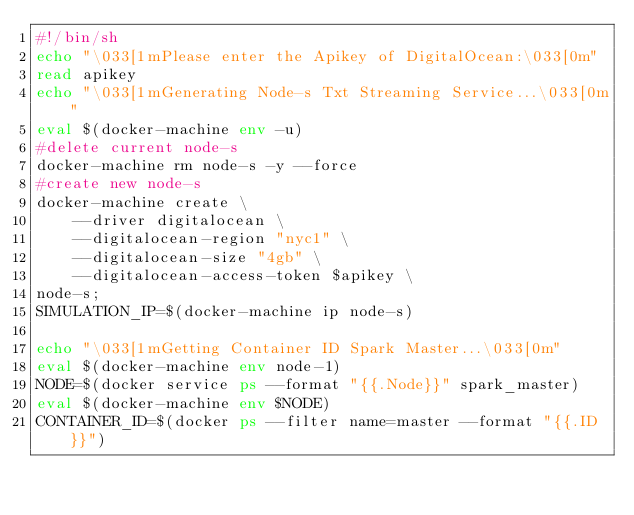Convert code to text. <code><loc_0><loc_0><loc_500><loc_500><_Bash_>#!/bin/sh
echo "\033[1mPlease enter the Apikey of DigitalOcean:\033[0m"
read apikey
echo "\033[1mGenerating Node-s Txt Streaming Service...\033[0m"
eval $(docker-machine env -u)
#delete current node-s
docker-machine rm node-s -y --force
#create new node-s 
docker-machine create \
    --driver digitalocean \
    --digitalocean-region "nyc1" \
    --digitalocean-size "4gb" \
    --digitalocean-access-token $apikey \
node-s;
SIMULATION_IP=$(docker-machine ip node-s)

echo "\033[1mGetting Container ID Spark Master...\033[0m"
eval $(docker-machine env node-1)
NODE=$(docker service ps --format "{{.Node}}" spark_master)
eval $(docker-machine env $NODE)
CONTAINER_ID=$(docker ps --filter name=master --format "{{.ID}}")
</code> 